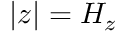Convert formula to latex. <formula><loc_0><loc_0><loc_500><loc_500>| z | = H _ { z }</formula> 